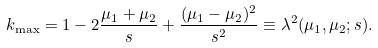<formula> <loc_0><loc_0><loc_500><loc_500>k _ { \max } = 1 - 2 \frac { \mu _ { 1 } + \mu _ { 2 } } { s } + \frac { ( \mu _ { 1 } - \mu _ { 2 } ) ^ { 2 } } { s ^ { 2 } } \equiv \lambda ^ { 2 } ( \mu _ { 1 } , \mu _ { 2 } ; s ) .</formula> 